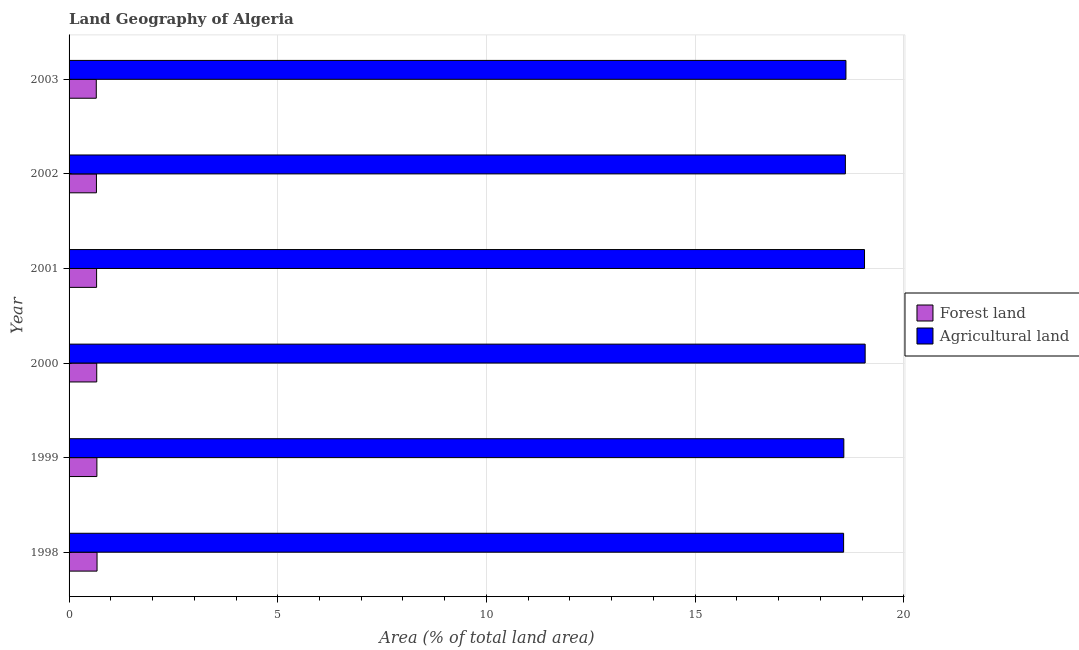How many groups of bars are there?
Your answer should be compact. 6. How many bars are there on the 1st tick from the bottom?
Your answer should be compact. 2. What is the percentage of land area under agriculture in 1999?
Make the answer very short. 18.56. Across all years, what is the maximum percentage of land area under agriculture?
Make the answer very short. 19.08. Across all years, what is the minimum percentage of land area under agriculture?
Make the answer very short. 18.56. In which year was the percentage of land area under forests maximum?
Offer a terse response. 1998. What is the total percentage of land area under agriculture in the graph?
Keep it short and to the point. 112.48. What is the difference between the percentage of land area under agriculture in 1998 and that in 1999?
Keep it short and to the point. -0.01. What is the difference between the percentage of land area under agriculture in 1999 and the percentage of land area under forests in 2001?
Your response must be concise. 17.91. What is the average percentage of land area under forests per year?
Give a very brief answer. 0.66. In the year 2001, what is the difference between the percentage of land area under agriculture and percentage of land area under forests?
Provide a short and direct response. 18.4. What is the ratio of the percentage of land area under agriculture in 1998 to that in 2001?
Offer a very short reply. 0.97. Is the percentage of land area under agriculture in 1999 less than that in 2002?
Provide a short and direct response. Yes. Is the difference between the percentage of land area under agriculture in 2000 and 2001 greater than the difference between the percentage of land area under forests in 2000 and 2001?
Provide a succinct answer. Yes. What is the difference between the highest and the second highest percentage of land area under forests?
Your answer should be very brief. 0. What is the difference between the highest and the lowest percentage of land area under forests?
Provide a succinct answer. 0.02. What does the 2nd bar from the top in 1998 represents?
Your answer should be compact. Forest land. What does the 2nd bar from the bottom in 1999 represents?
Your response must be concise. Agricultural land. Are all the bars in the graph horizontal?
Your answer should be very brief. Yes. What is the difference between two consecutive major ticks on the X-axis?
Provide a succinct answer. 5. Are the values on the major ticks of X-axis written in scientific E-notation?
Offer a very short reply. No. Where does the legend appear in the graph?
Provide a succinct answer. Center right. How are the legend labels stacked?
Your response must be concise. Vertical. What is the title of the graph?
Your response must be concise. Land Geography of Algeria. Does "GDP per capita" appear as one of the legend labels in the graph?
Give a very brief answer. No. What is the label or title of the X-axis?
Provide a succinct answer. Area (% of total land area). What is the label or title of the Y-axis?
Offer a very short reply. Year. What is the Area (% of total land area) of Forest land in 1998?
Give a very brief answer. 0.67. What is the Area (% of total land area) of Agricultural land in 1998?
Your answer should be very brief. 18.56. What is the Area (% of total land area) of Forest land in 1999?
Provide a succinct answer. 0.67. What is the Area (% of total land area) of Agricultural land in 1999?
Offer a terse response. 18.56. What is the Area (% of total land area) in Forest land in 2000?
Offer a very short reply. 0.66. What is the Area (% of total land area) of Agricultural land in 2000?
Offer a very short reply. 19.08. What is the Area (% of total land area) in Forest land in 2001?
Your answer should be very brief. 0.66. What is the Area (% of total land area) in Agricultural land in 2001?
Ensure brevity in your answer.  19.06. What is the Area (% of total land area) in Forest land in 2002?
Provide a short and direct response. 0.66. What is the Area (% of total land area) of Agricultural land in 2002?
Offer a terse response. 18.6. What is the Area (% of total land area) in Forest land in 2003?
Offer a very short reply. 0.65. What is the Area (% of total land area) in Agricultural land in 2003?
Offer a terse response. 18.61. Across all years, what is the maximum Area (% of total land area) in Forest land?
Give a very brief answer. 0.67. Across all years, what is the maximum Area (% of total land area) of Agricultural land?
Offer a terse response. 19.08. Across all years, what is the minimum Area (% of total land area) in Forest land?
Your answer should be very brief. 0.65. Across all years, what is the minimum Area (% of total land area) in Agricultural land?
Your answer should be compact. 18.56. What is the total Area (% of total land area) of Forest land in the graph?
Keep it short and to the point. 3.97. What is the total Area (% of total land area) in Agricultural land in the graph?
Provide a succinct answer. 112.48. What is the difference between the Area (% of total land area) in Forest land in 1998 and that in 1999?
Offer a very short reply. 0. What is the difference between the Area (% of total land area) of Agricultural land in 1998 and that in 1999?
Your response must be concise. -0.01. What is the difference between the Area (% of total land area) of Forest land in 1998 and that in 2000?
Your answer should be compact. 0.01. What is the difference between the Area (% of total land area) of Agricultural land in 1998 and that in 2000?
Offer a very short reply. -0.52. What is the difference between the Area (% of total land area) in Forest land in 1998 and that in 2001?
Keep it short and to the point. 0.01. What is the difference between the Area (% of total land area) of Agricultural land in 1998 and that in 2001?
Give a very brief answer. -0.5. What is the difference between the Area (% of total land area) in Forest land in 1998 and that in 2002?
Provide a short and direct response. 0.01. What is the difference between the Area (% of total land area) of Agricultural land in 1998 and that in 2002?
Your response must be concise. -0.04. What is the difference between the Area (% of total land area) in Forest land in 1998 and that in 2003?
Keep it short and to the point. 0.02. What is the difference between the Area (% of total land area) of Agricultural land in 1998 and that in 2003?
Provide a succinct answer. -0.06. What is the difference between the Area (% of total land area) in Forest land in 1999 and that in 2000?
Provide a short and direct response. 0. What is the difference between the Area (% of total land area) in Agricultural land in 1999 and that in 2000?
Ensure brevity in your answer.  -0.51. What is the difference between the Area (% of total land area) in Forest land in 1999 and that in 2001?
Provide a succinct answer. 0.01. What is the difference between the Area (% of total land area) in Agricultural land in 1999 and that in 2001?
Your answer should be compact. -0.5. What is the difference between the Area (% of total land area) in Forest land in 1999 and that in 2002?
Keep it short and to the point. 0.01. What is the difference between the Area (% of total land area) in Agricultural land in 1999 and that in 2002?
Give a very brief answer. -0.04. What is the difference between the Area (% of total land area) in Forest land in 1999 and that in 2003?
Your answer should be compact. 0.01. What is the difference between the Area (% of total land area) of Agricultural land in 1999 and that in 2003?
Give a very brief answer. -0.05. What is the difference between the Area (% of total land area) in Forest land in 2000 and that in 2001?
Make the answer very short. 0. What is the difference between the Area (% of total land area) of Agricultural land in 2000 and that in 2001?
Your response must be concise. 0.02. What is the difference between the Area (% of total land area) of Forest land in 2000 and that in 2002?
Keep it short and to the point. 0.01. What is the difference between the Area (% of total land area) of Agricultural land in 2000 and that in 2002?
Your answer should be very brief. 0.47. What is the difference between the Area (% of total land area) of Forest land in 2000 and that in 2003?
Give a very brief answer. 0.01. What is the difference between the Area (% of total land area) in Agricultural land in 2000 and that in 2003?
Give a very brief answer. 0.46. What is the difference between the Area (% of total land area) in Forest land in 2001 and that in 2002?
Keep it short and to the point. 0. What is the difference between the Area (% of total land area) of Agricultural land in 2001 and that in 2002?
Offer a terse response. 0.46. What is the difference between the Area (% of total land area) in Forest land in 2001 and that in 2003?
Provide a short and direct response. 0.01. What is the difference between the Area (% of total land area) of Agricultural land in 2001 and that in 2003?
Make the answer very short. 0.45. What is the difference between the Area (% of total land area) of Forest land in 2002 and that in 2003?
Your answer should be compact. 0. What is the difference between the Area (% of total land area) in Agricultural land in 2002 and that in 2003?
Your answer should be compact. -0.01. What is the difference between the Area (% of total land area) in Forest land in 1998 and the Area (% of total land area) in Agricultural land in 1999?
Give a very brief answer. -17.89. What is the difference between the Area (% of total land area) in Forest land in 1998 and the Area (% of total land area) in Agricultural land in 2000?
Keep it short and to the point. -18.41. What is the difference between the Area (% of total land area) of Forest land in 1998 and the Area (% of total land area) of Agricultural land in 2001?
Provide a short and direct response. -18.39. What is the difference between the Area (% of total land area) in Forest land in 1998 and the Area (% of total land area) in Agricultural land in 2002?
Keep it short and to the point. -17.93. What is the difference between the Area (% of total land area) in Forest land in 1998 and the Area (% of total land area) in Agricultural land in 2003?
Give a very brief answer. -17.94. What is the difference between the Area (% of total land area) in Forest land in 1999 and the Area (% of total land area) in Agricultural land in 2000?
Offer a very short reply. -18.41. What is the difference between the Area (% of total land area) of Forest land in 1999 and the Area (% of total land area) of Agricultural land in 2001?
Offer a terse response. -18.39. What is the difference between the Area (% of total land area) in Forest land in 1999 and the Area (% of total land area) in Agricultural land in 2002?
Offer a terse response. -17.93. What is the difference between the Area (% of total land area) of Forest land in 1999 and the Area (% of total land area) of Agricultural land in 2003?
Provide a succinct answer. -17.95. What is the difference between the Area (% of total land area) in Forest land in 2000 and the Area (% of total land area) in Agricultural land in 2001?
Give a very brief answer. -18.4. What is the difference between the Area (% of total land area) in Forest land in 2000 and the Area (% of total land area) in Agricultural land in 2002?
Provide a short and direct response. -17.94. What is the difference between the Area (% of total land area) of Forest land in 2000 and the Area (% of total land area) of Agricultural land in 2003?
Make the answer very short. -17.95. What is the difference between the Area (% of total land area) of Forest land in 2001 and the Area (% of total land area) of Agricultural land in 2002?
Your answer should be very brief. -17.94. What is the difference between the Area (% of total land area) in Forest land in 2001 and the Area (% of total land area) in Agricultural land in 2003?
Provide a succinct answer. -17.96. What is the difference between the Area (% of total land area) in Forest land in 2002 and the Area (% of total land area) in Agricultural land in 2003?
Your response must be concise. -17.96. What is the average Area (% of total land area) of Forest land per year?
Provide a short and direct response. 0.66. What is the average Area (% of total land area) of Agricultural land per year?
Your response must be concise. 18.75. In the year 1998, what is the difference between the Area (% of total land area) in Forest land and Area (% of total land area) in Agricultural land?
Provide a short and direct response. -17.89. In the year 1999, what is the difference between the Area (% of total land area) in Forest land and Area (% of total land area) in Agricultural land?
Offer a very short reply. -17.9. In the year 2000, what is the difference between the Area (% of total land area) of Forest land and Area (% of total land area) of Agricultural land?
Offer a terse response. -18.41. In the year 2001, what is the difference between the Area (% of total land area) of Forest land and Area (% of total land area) of Agricultural land?
Offer a terse response. -18.4. In the year 2002, what is the difference between the Area (% of total land area) in Forest land and Area (% of total land area) in Agricultural land?
Give a very brief answer. -17.95. In the year 2003, what is the difference between the Area (% of total land area) in Forest land and Area (% of total land area) in Agricultural land?
Offer a very short reply. -17.96. What is the ratio of the Area (% of total land area) of Agricultural land in 1998 to that in 1999?
Keep it short and to the point. 1. What is the ratio of the Area (% of total land area) in Forest land in 1998 to that in 2000?
Your answer should be compact. 1.01. What is the ratio of the Area (% of total land area) in Agricultural land in 1998 to that in 2000?
Provide a short and direct response. 0.97. What is the ratio of the Area (% of total land area) of Forest land in 1998 to that in 2001?
Your answer should be compact. 1.02. What is the ratio of the Area (% of total land area) in Agricultural land in 1998 to that in 2001?
Ensure brevity in your answer.  0.97. What is the ratio of the Area (% of total land area) of Forest land in 1998 to that in 2002?
Offer a very short reply. 1.02. What is the ratio of the Area (% of total land area) of Agricultural land in 1998 to that in 2002?
Offer a very short reply. 1. What is the ratio of the Area (% of total land area) in Forest land in 1998 to that in 2003?
Your answer should be compact. 1.03. What is the ratio of the Area (% of total land area) of Agricultural land in 1998 to that in 2003?
Provide a succinct answer. 1. What is the ratio of the Area (% of total land area) of Forest land in 1999 to that in 2000?
Keep it short and to the point. 1.01. What is the ratio of the Area (% of total land area) in Agricultural land in 1999 to that in 2000?
Provide a succinct answer. 0.97. What is the ratio of the Area (% of total land area) of Forest land in 1999 to that in 2001?
Your answer should be compact. 1.01. What is the ratio of the Area (% of total land area) in Agricultural land in 1999 to that in 2001?
Provide a succinct answer. 0.97. What is the ratio of the Area (% of total land area) in Forest land in 1999 to that in 2002?
Give a very brief answer. 1.02. What is the ratio of the Area (% of total land area) of Agricultural land in 1999 to that in 2002?
Make the answer very short. 1. What is the ratio of the Area (% of total land area) in Forest land in 1999 to that in 2003?
Provide a short and direct response. 1.02. What is the ratio of the Area (% of total land area) of Agricultural land in 1999 to that in 2003?
Your response must be concise. 1. What is the ratio of the Area (% of total land area) in Agricultural land in 2000 to that in 2001?
Offer a very short reply. 1. What is the ratio of the Area (% of total land area) in Agricultural land in 2000 to that in 2002?
Your answer should be compact. 1.03. What is the ratio of the Area (% of total land area) in Forest land in 2000 to that in 2003?
Your answer should be compact. 1.02. What is the ratio of the Area (% of total land area) in Agricultural land in 2000 to that in 2003?
Your answer should be very brief. 1.02. What is the ratio of the Area (% of total land area) of Agricultural land in 2001 to that in 2002?
Provide a succinct answer. 1.02. What is the ratio of the Area (% of total land area) in Forest land in 2001 to that in 2003?
Give a very brief answer. 1.01. What is the ratio of the Area (% of total land area) in Agricultural land in 2001 to that in 2003?
Keep it short and to the point. 1.02. What is the ratio of the Area (% of total land area) in Forest land in 2002 to that in 2003?
Give a very brief answer. 1.01. What is the difference between the highest and the second highest Area (% of total land area) in Forest land?
Offer a very short reply. 0. What is the difference between the highest and the second highest Area (% of total land area) in Agricultural land?
Your answer should be compact. 0.02. What is the difference between the highest and the lowest Area (% of total land area) of Forest land?
Provide a succinct answer. 0.02. What is the difference between the highest and the lowest Area (% of total land area) in Agricultural land?
Make the answer very short. 0.52. 